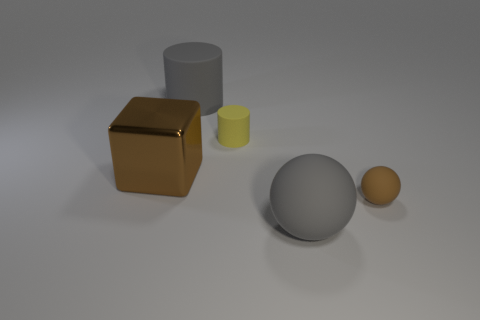Add 4 gray spheres. How many objects exist? 9 Subtract all cubes. How many objects are left? 4 Add 4 big green metal objects. How many big green metal objects exist? 4 Subtract 1 gray cylinders. How many objects are left? 4 Subtract all gray matte cylinders. Subtract all brown matte balls. How many objects are left? 3 Add 1 tiny brown objects. How many tiny brown objects are left? 2 